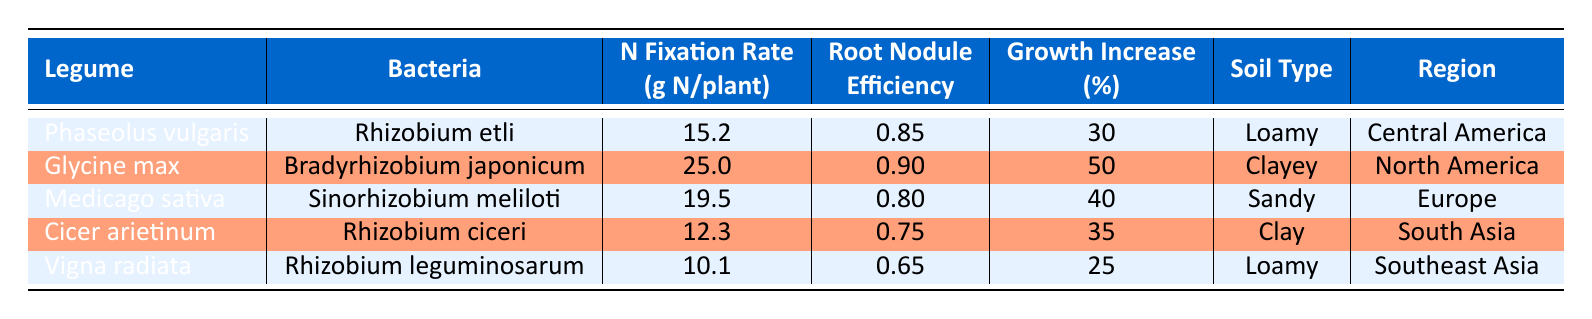What is the nitrogen fixation rate for Glycine max? The table lists the nitrogen fixation rate for Glycine max under the "Nitrogen Fixation Rate (g N/plant)" column, which directly states the value of 25.0.
Answer: 25.0 Which legume has the highest root nodule efficiency? By comparing the "Root Nodule Efficiency" values in the table, Glycine max has the highest value of 0.90.
Answer: Glycine max What is the growth increase percent for Cicer arietinum? The "Growth Increase (%)" column indicates that the growth increase percent for Cicer arietinum is 35.
Answer: 35 Calculate the average nitrogen fixation rate for the legumes listed. The nitrogen fixation rates are 15.2, 25.0, 19.5, 12.3, and 10.1. Summing them gives 15.2 + 25.0 + 19.5 + 12.3 + 10.1 = 82.1. Dividing by the number of legumes (5) results in an average of 82.1/5 = 16.42.
Answer: 16.42 Is the root nodule efficiency of Vigna radiata greater than 0.7? By checking the "Root Nodule Efficiency" column, Vigna radiata has a value of 0.65, which is not greater than 0.7.
Answer: No Which legume has the lowest growth increase percent? The "Growth Increase (%)" values indicate that Vigna radiata has the lowest percent at 25.
Answer: Vigna radiata How many legumes have a nitrogen fixation rate greater than 15 grams per plant? Filtering through the "Nitrogen Fixation Rate (g N/plant)" column, the legumes with rates greater than 15 are Glycine max (25.0), Medicago sativa (19.5), and Phaseolus vulgaris (15.2), totaling three legumes.
Answer: 3 Does Cicer arietinum have a higher nitrogen fixation rate than Vigna radiata? By comparing their nitrogen fixation rates, Cicer arietinum has a rate of 12.3 and Vigna radiata has a rate of 10.1. Since 12.3 is greater than 10.1, the statement is true.
Answer: Yes Which soil type is associated with Meridoca sativa? The "Soil Type" column states that Medicago sativa is associated with Sandy soil.
Answer: Sandy 